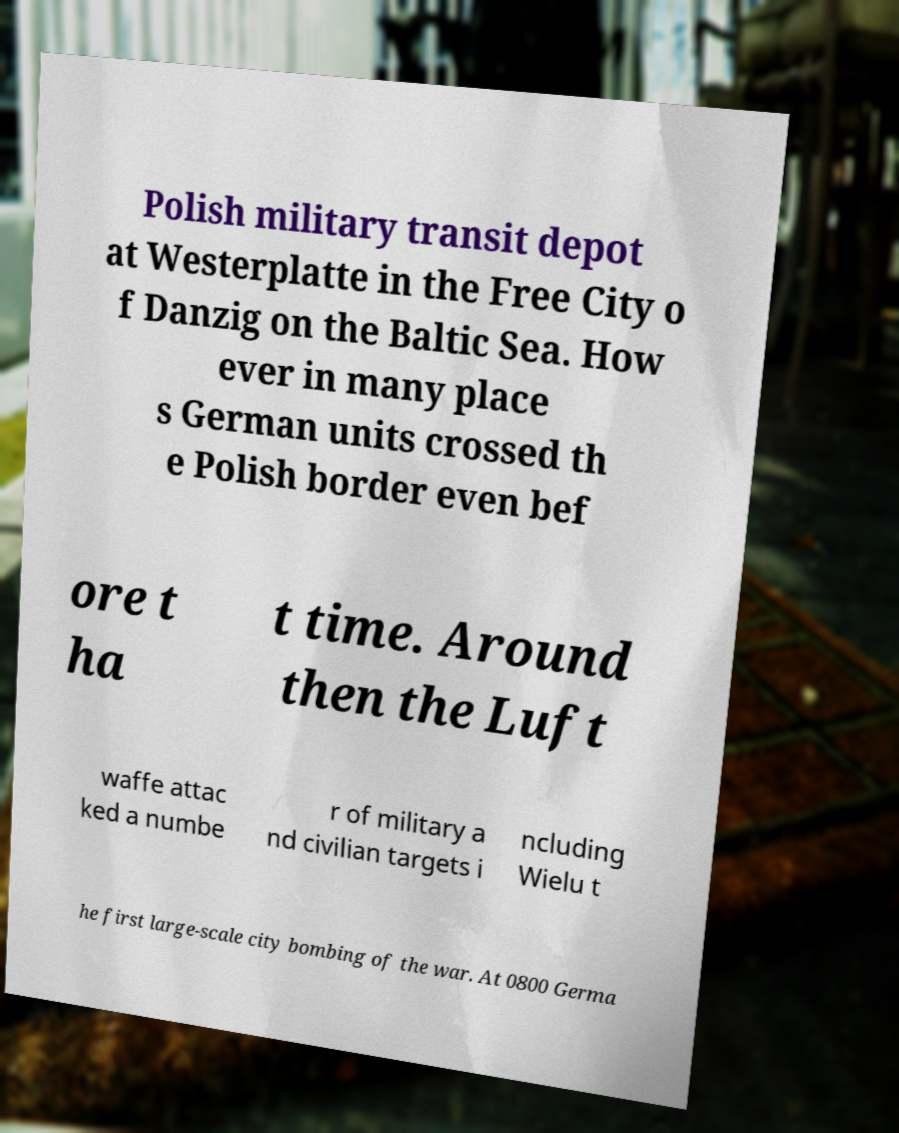For documentation purposes, I need the text within this image transcribed. Could you provide that? Polish military transit depot at Westerplatte in the Free City o f Danzig on the Baltic Sea. How ever in many place s German units crossed th e Polish border even bef ore t ha t time. Around then the Luft waffe attac ked a numbe r of military a nd civilian targets i ncluding Wielu t he first large-scale city bombing of the war. At 0800 Germa 